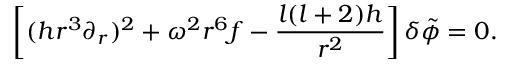<formula> <loc_0><loc_0><loc_500><loc_500>\left [ ( h r ^ { 3 } \partial _ { r } ) ^ { 2 } + \omega ^ { 2 } r ^ { 6 } f - { \frac { l ( l + 2 ) h } { r ^ { 2 } } } \right ] \delta \tilde { \phi } = 0 .</formula> 